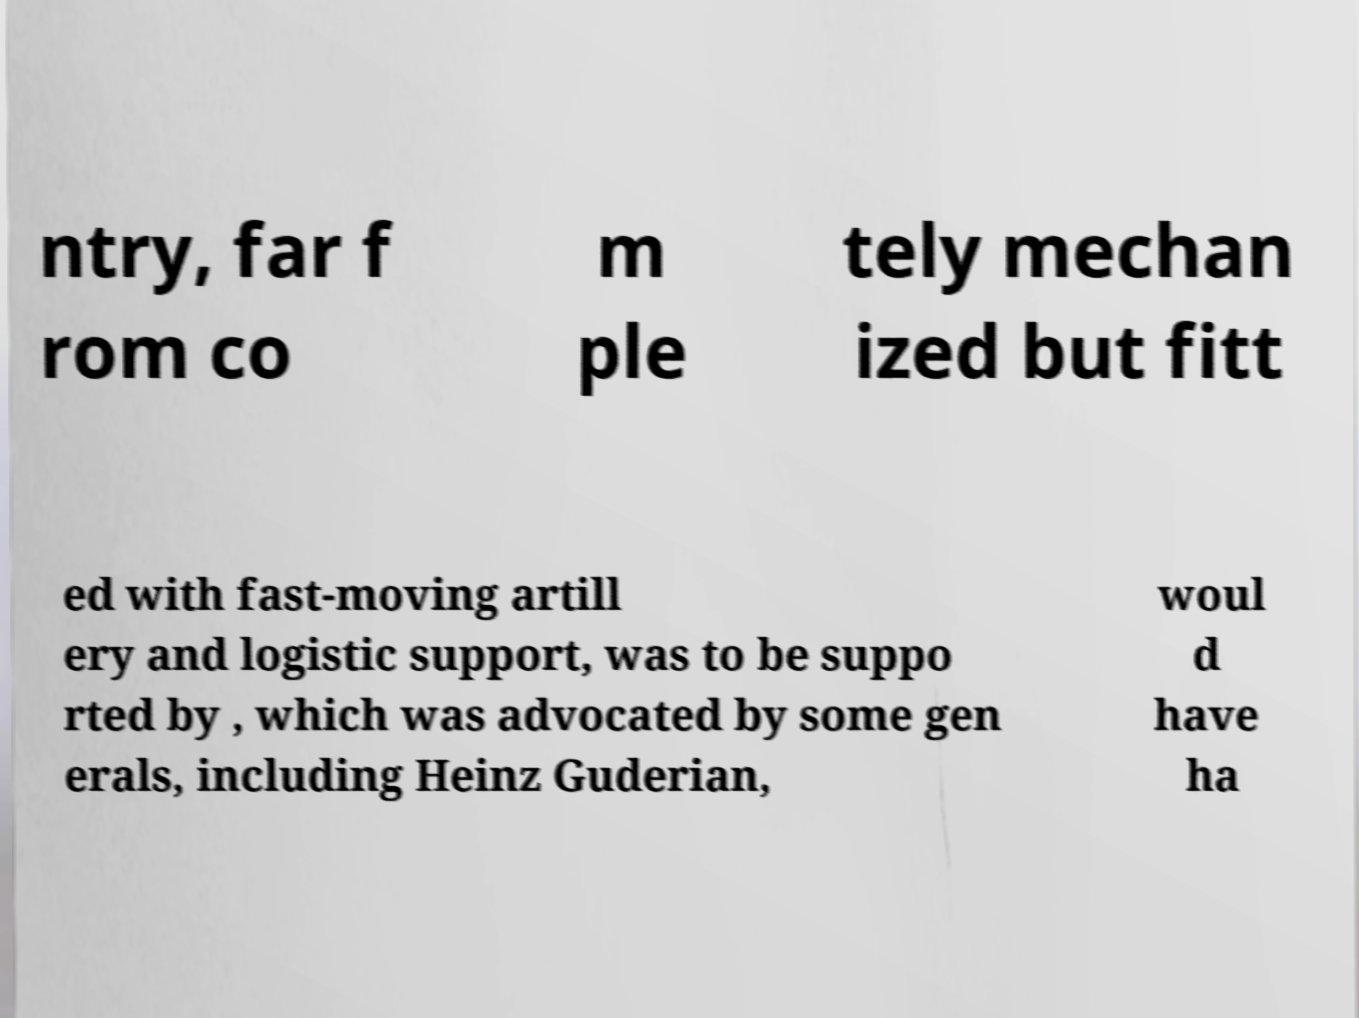Can you accurately transcribe the text from the provided image for me? ntry, far f rom co m ple tely mechan ized but fitt ed with fast-moving artill ery and logistic support, was to be suppo rted by , which was advocated by some gen erals, including Heinz Guderian, woul d have ha 